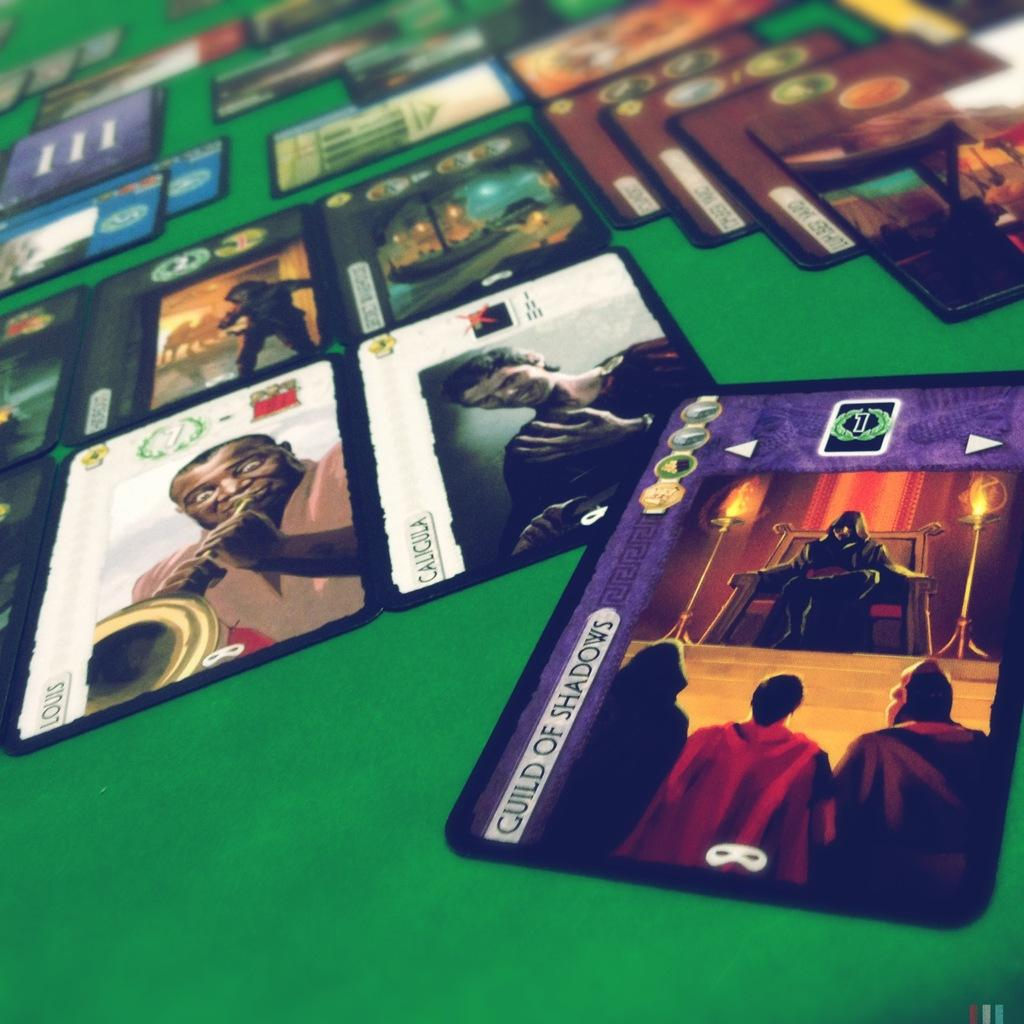What objects are present in the image? There are cards in the image. What is the background of the image? The cards are lying on a green background. What can be seen on the cards? The cards have depictions, cartoons, and other images. Are there any words on the cards? Yes, the cards have text on them. How many geese are swimming around the island depicted on one of the cards? There is no island or geese depicted on any of the cards in the image. 